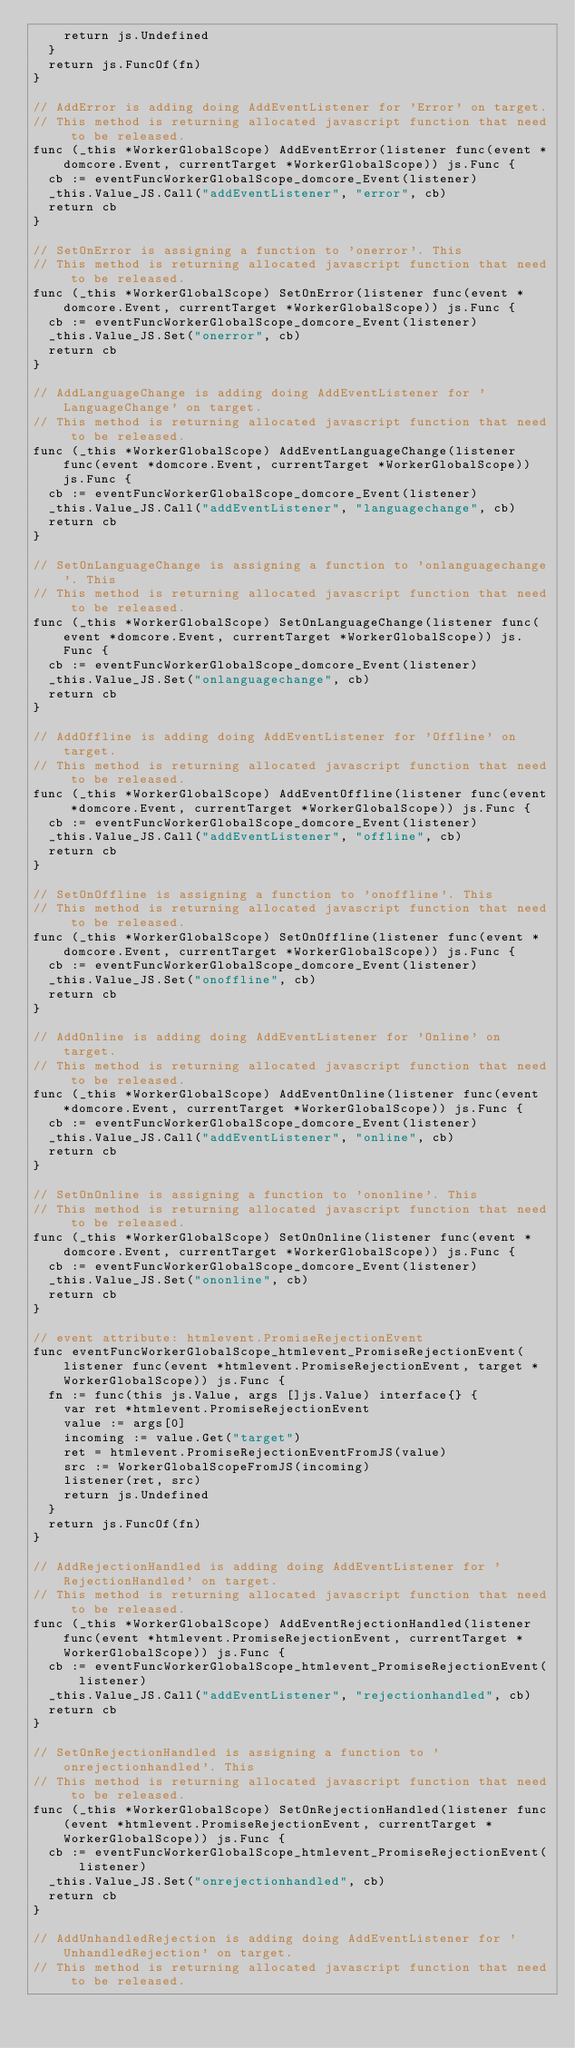<code> <loc_0><loc_0><loc_500><loc_500><_Go_>		return js.Undefined
	}
	return js.FuncOf(fn)
}

// AddError is adding doing AddEventListener for 'Error' on target.
// This method is returning allocated javascript function that need to be released.
func (_this *WorkerGlobalScope) AddEventError(listener func(event *domcore.Event, currentTarget *WorkerGlobalScope)) js.Func {
	cb := eventFuncWorkerGlobalScope_domcore_Event(listener)
	_this.Value_JS.Call("addEventListener", "error", cb)
	return cb
}

// SetOnError is assigning a function to 'onerror'. This
// This method is returning allocated javascript function that need to be released.
func (_this *WorkerGlobalScope) SetOnError(listener func(event *domcore.Event, currentTarget *WorkerGlobalScope)) js.Func {
	cb := eventFuncWorkerGlobalScope_domcore_Event(listener)
	_this.Value_JS.Set("onerror", cb)
	return cb
}

// AddLanguageChange is adding doing AddEventListener for 'LanguageChange' on target.
// This method is returning allocated javascript function that need to be released.
func (_this *WorkerGlobalScope) AddEventLanguageChange(listener func(event *domcore.Event, currentTarget *WorkerGlobalScope)) js.Func {
	cb := eventFuncWorkerGlobalScope_domcore_Event(listener)
	_this.Value_JS.Call("addEventListener", "languagechange", cb)
	return cb
}

// SetOnLanguageChange is assigning a function to 'onlanguagechange'. This
// This method is returning allocated javascript function that need to be released.
func (_this *WorkerGlobalScope) SetOnLanguageChange(listener func(event *domcore.Event, currentTarget *WorkerGlobalScope)) js.Func {
	cb := eventFuncWorkerGlobalScope_domcore_Event(listener)
	_this.Value_JS.Set("onlanguagechange", cb)
	return cb
}

// AddOffline is adding doing AddEventListener for 'Offline' on target.
// This method is returning allocated javascript function that need to be released.
func (_this *WorkerGlobalScope) AddEventOffline(listener func(event *domcore.Event, currentTarget *WorkerGlobalScope)) js.Func {
	cb := eventFuncWorkerGlobalScope_domcore_Event(listener)
	_this.Value_JS.Call("addEventListener", "offline", cb)
	return cb
}

// SetOnOffline is assigning a function to 'onoffline'. This
// This method is returning allocated javascript function that need to be released.
func (_this *WorkerGlobalScope) SetOnOffline(listener func(event *domcore.Event, currentTarget *WorkerGlobalScope)) js.Func {
	cb := eventFuncWorkerGlobalScope_domcore_Event(listener)
	_this.Value_JS.Set("onoffline", cb)
	return cb
}

// AddOnline is adding doing AddEventListener for 'Online' on target.
// This method is returning allocated javascript function that need to be released.
func (_this *WorkerGlobalScope) AddEventOnline(listener func(event *domcore.Event, currentTarget *WorkerGlobalScope)) js.Func {
	cb := eventFuncWorkerGlobalScope_domcore_Event(listener)
	_this.Value_JS.Call("addEventListener", "online", cb)
	return cb
}

// SetOnOnline is assigning a function to 'ononline'. This
// This method is returning allocated javascript function that need to be released.
func (_this *WorkerGlobalScope) SetOnOnline(listener func(event *domcore.Event, currentTarget *WorkerGlobalScope)) js.Func {
	cb := eventFuncWorkerGlobalScope_domcore_Event(listener)
	_this.Value_JS.Set("ononline", cb)
	return cb
}

// event attribute: htmlevent.PromiseRejectionEvent
func eventFuncWorkerGlobalScope_htmlevent_PromiseRejectionEvent(listener func(event *htmlevent.PromiseRejectionEvent, target *WorkerGlobalScope)) js.Func {
	fn := func(this js.Value, args []js.Value) interface{} {
		var ret *htmlevent.PromiseRejectionEvent
		value := args[0]
		incoming := value.Get("target")
		ret = htmlevent.PromiseRejectionEventFromJS(value)
		src := WorkerGlobalScopeFromJS(incoming)
		listener(ret, src)
		return js.Undefined
	}
	return js.FuncOf(fn)
}

// AddRejectionHandled is adding doing AddEventListener for 'RejectionHandled' on target.
// This method is returning allocated javascript function that need to be released.
func (_this *WorkerGlobalScope) AddEventRejectionHandled(listener func(event *htmlevent.PromiseRejectionEvent, currentTarget *WorkerGlobalScope)) js.Func {
	cb := eventFuncWorkerGlobalScope_htmlevent_PromiseRejectionEvent(listener)
	_this.Value_JS.Call("addEventListener", "rejectionhandled", cb)
	return cb
}

// SetOnRejectionHandled is assigning a function to 'onrejectionhandled'. This
// This method is returning allocated javascript function that need to be released.
func (_this *WorkerGlobalScope) SetOnRejectionHandled(listener func(event *htmlevent.PromiseRejectionEvent, currentTarget *WorkerGlobalScope)) js.Func {
	cb := eventFuncWorkerGlobalScope_htmlevent_PromiseRejectionEvent(listener)
	_this.Value_JS.Set("onrejectionhandled", cb)
	return cb
}

// AddUnhandledRejection is adding doing AddEventListener for 'UnhandledRejection' on target.
// This method is returning allocated javascript function that need to be released.</code> 